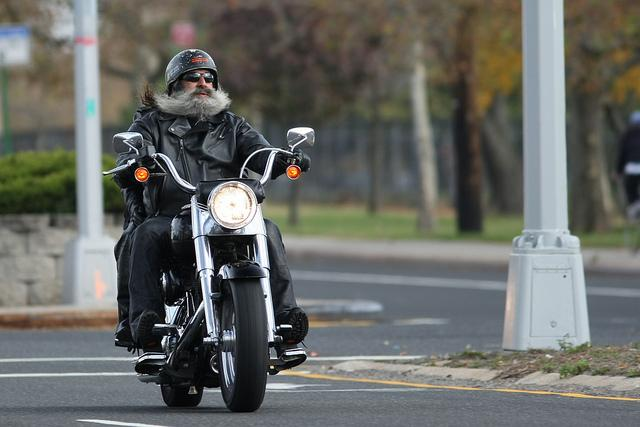What does the brown hair belong to? Please explain your reasoning. someone's hair. The motorcycler's beard has a bit of brown on the ends. 